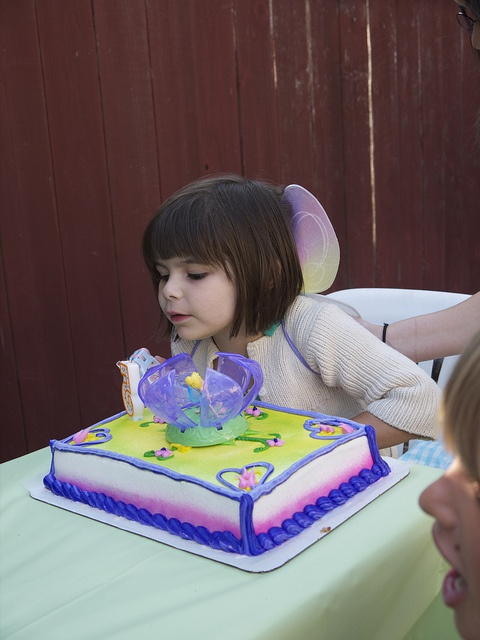Describe the objects in this image and their specific colors. I can see people in black, darkgray, lightgray, and gray tones, cake in black, darkgray, darkblue, lightgray, and blue tones, people in black, gray, and maroon tones, chair in black, lavender, darkgray, and gray tones, and people in black, darkgray, and gray tones in this image. 